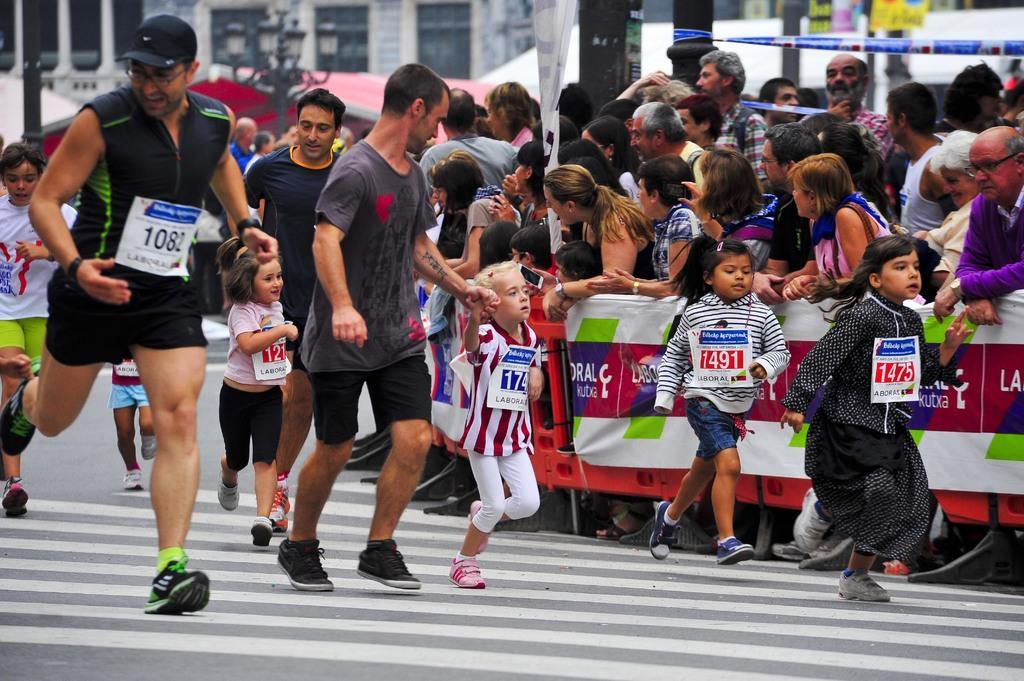Please provide a concise description of this image. In this image I can see few people on the road in a marathon with kids and I can see a group of people standing and watching and I can see a building behind them.  